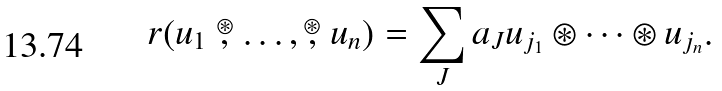Convert formula to latex. <formula><loc_0><loc_0><loc_500><loc_500>r ( u _ { 1 } \stackrel { \circledast } { , } \dots , \stackrel { \circledast } { , } u _ { n } ) = \sum _ { J } a _ { J } u _ { j _ { 1 } } \circledast \dots \circledast u _ { j _ { n } } .</formula> 